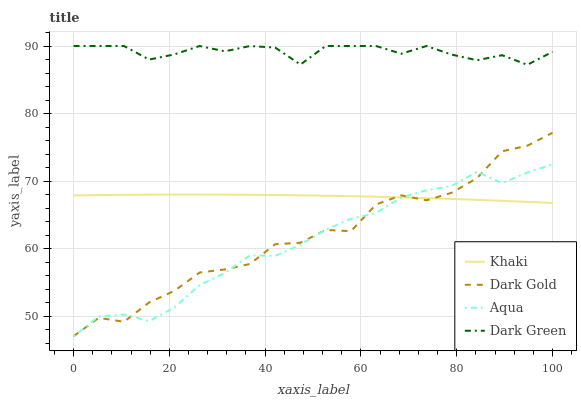Does Aqua have the minimum area under the curve?
Answer yes or no. Yes. Does Dark Green have the maximum area under the curve?
Answer yes or no. Yes. Does Dark Green have the minimum area under the curve?
Answer yes or no. No. Does Aqua have the maximum area under the curve?
Answer yes or no. No. Is Khaki the smoothest?
Answer yes or no. Yes. Is Dark Gold the roughest?
Answer yes or no. Yes. Is Aqua the smoothest?
Answer yes or no. No. Is Aqua the roughest?
Answer yes or no. No. Does Aqua have the lowest value?
Answer yes or no. Yes. Does Dark Green have the lowest value?
Answer yes or no. No. Does Dark Green have the highest value?
Answer yes or no. Yes. Does Aqua have the highest value?
Answer yes or no. No. Is Dark Gold less than Dark Green?
Answer yes or no. Yes. Is Dark Green greater than Dark Gold?
Answer yes or no. Yes. Does Dark Gold intersect Aqua?
Answer yes or no. Yes. Is Dark Gold less than Aqua?
Answer yes or no. No. Is Dark Gold greater than Aqua?
Answer yes or no. No. Does Dark Gold intersect Dark Green?
Answer yes or no. No. 